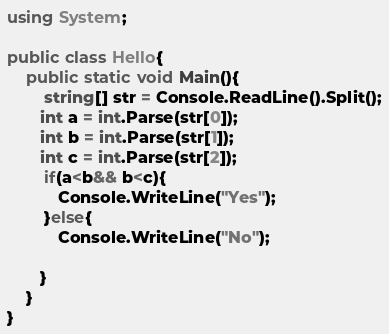<code> <loc_0><loc_0><loc_500><loc_500><_C#_>using System;

public class Hello{
    public static void Main(){
        string[] str = Console.ReadLine().Split();
       int a = int.Parse(str[0]);
       int b = int.Parse(str[1]);
       int c = int.Parse(str[2]);
        if(a<b&& b<c){
           Console.WriteLine("Yes");
        }else{  
           Console.WriteLine("No");
           
       }
    }
}
</code> 